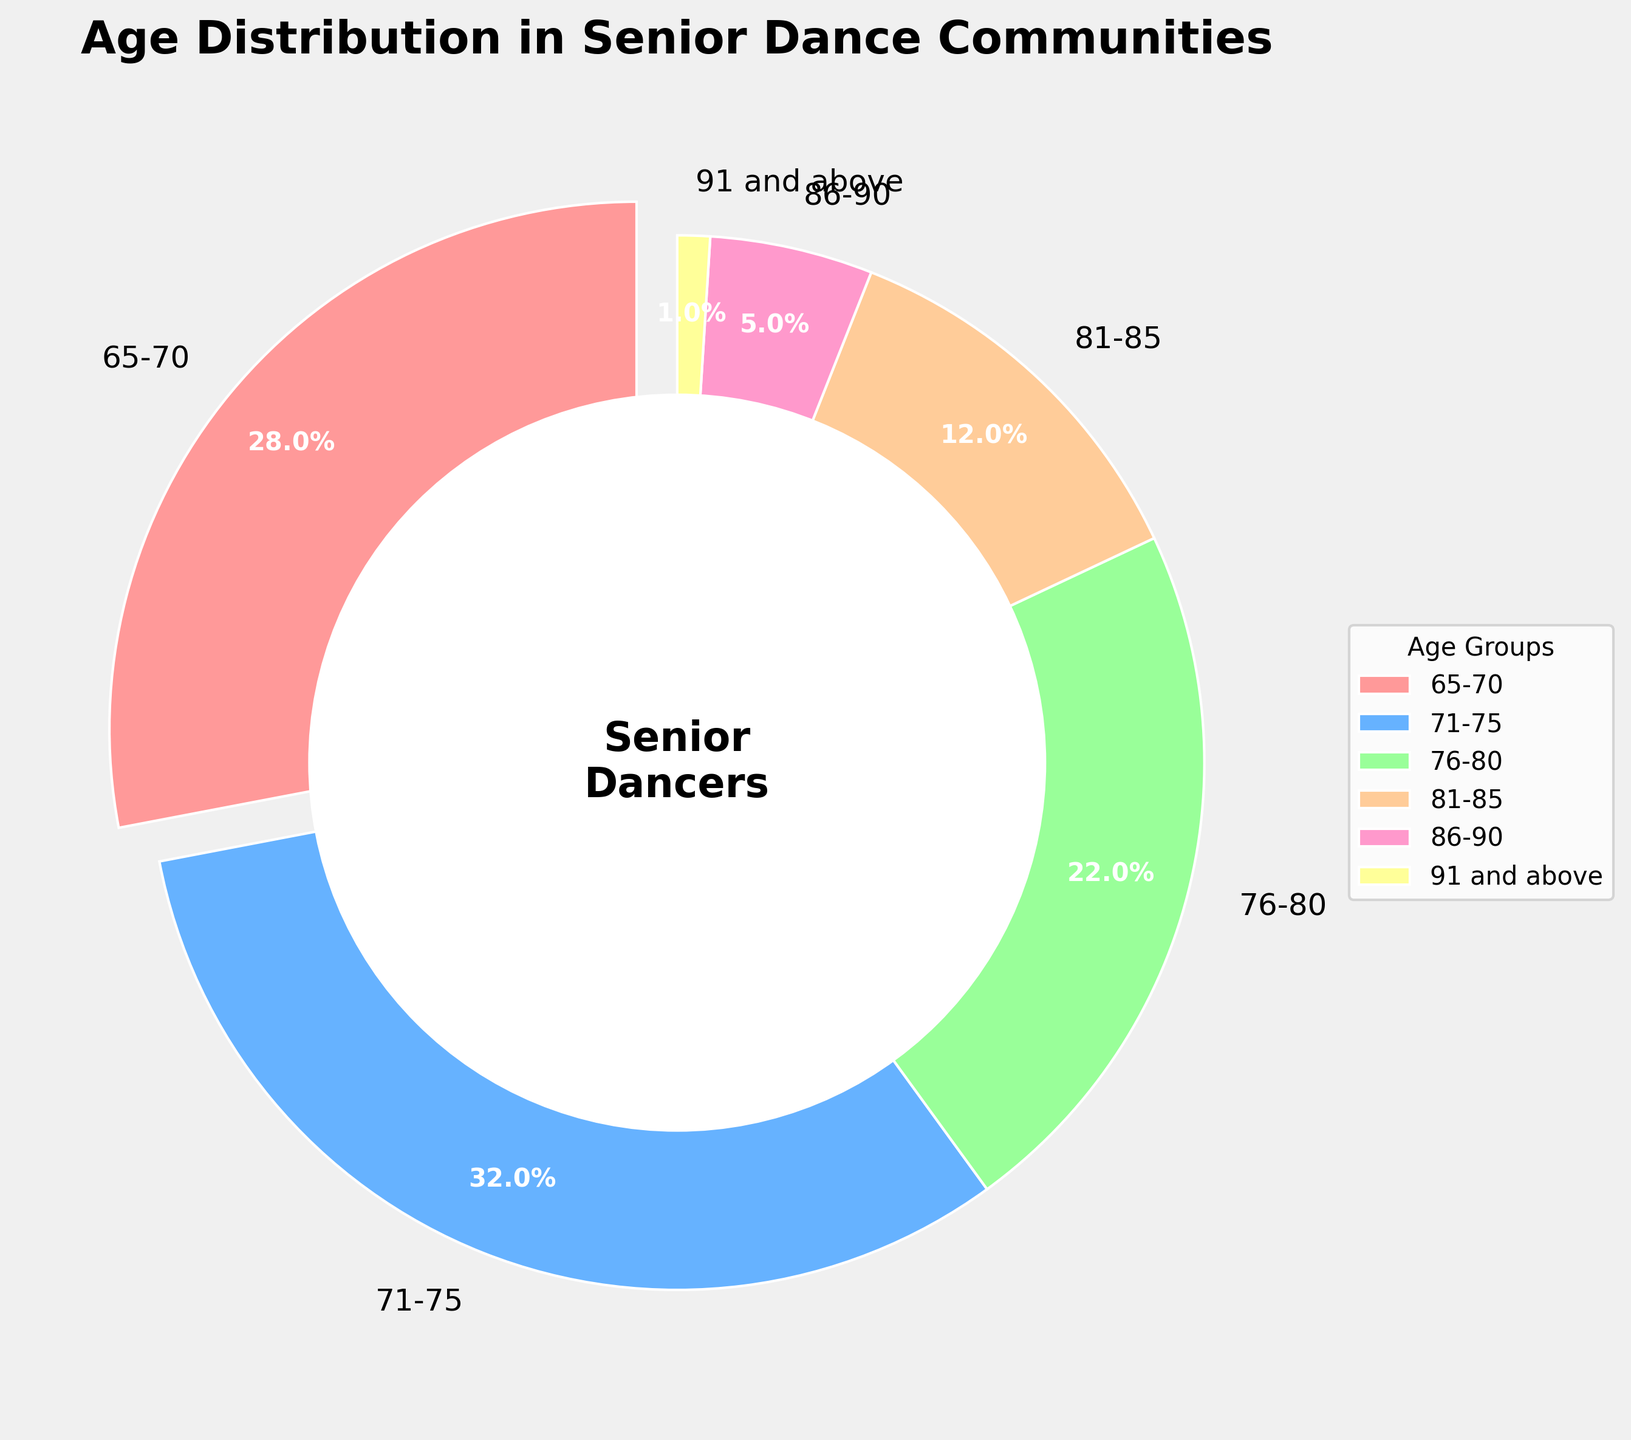What age group has the highest percentage of members in the senior dance communities? The pie chart shows the different age groups and their corresponding percentages. By visually inspecting the chart, we see that the 71-75 age group has the largest slice.
Answer: 71-75 What is the combined percentage of the two oldest age groups (86-90 and 91 and above)? To find the combined percentage, add the percentages of the 86-90 and 91 and above age groups. From the chart, these are 5% and 1%, respectively. The combined percentage is 5% + 1% = 6%.
Answer: 6% Which age group has a slightly larger percentage, the 65-70 age group or the 76-80 age group? By comparing the slices of the 65-70 (28%) and 76-80 (22%) age groups, we see that the 65-70 age group is larger.
Answer: 65-70 What is the difference in the percentage between the 71-75 and the 81-85 age groups? To find the difference, subtract the percentage of the 81-85 age group (12%) from the percentage of the 71-75 age group (32%). 32% - 12% = 20%.
Answer: 20% What percentage of dancers are younger than 76-80? Add the percentages of the 65-70 (28%) and 71-75 (32%) age groups. 28% + 32% = 60%.
Answer: 60% How many age groups have a percentage of 10% or higher? Count the number of age groups with percentage labels of 10% or higher: 65-70 (28%), 71-75 (32%), 76-80 (22%), and 81-85 (12%). There are 4 such age groups.
Answer: 4 What is the total percentage representation of dancers aged 80 and above? Add the percentages of the 81-85 (12%), 86-90 (5%), and 91 and above (1%) age groups. 12% + 5% + 1% = 18%.
Answer: 18% Which age group colors are used in the chart? By inspecting the slices of the pie chart visually, the colors used for the age groups are a pinkish red, blue, green, orange, pink, and yellow.
Answer: pinkish red, blue, green, orange, pink, yellow 